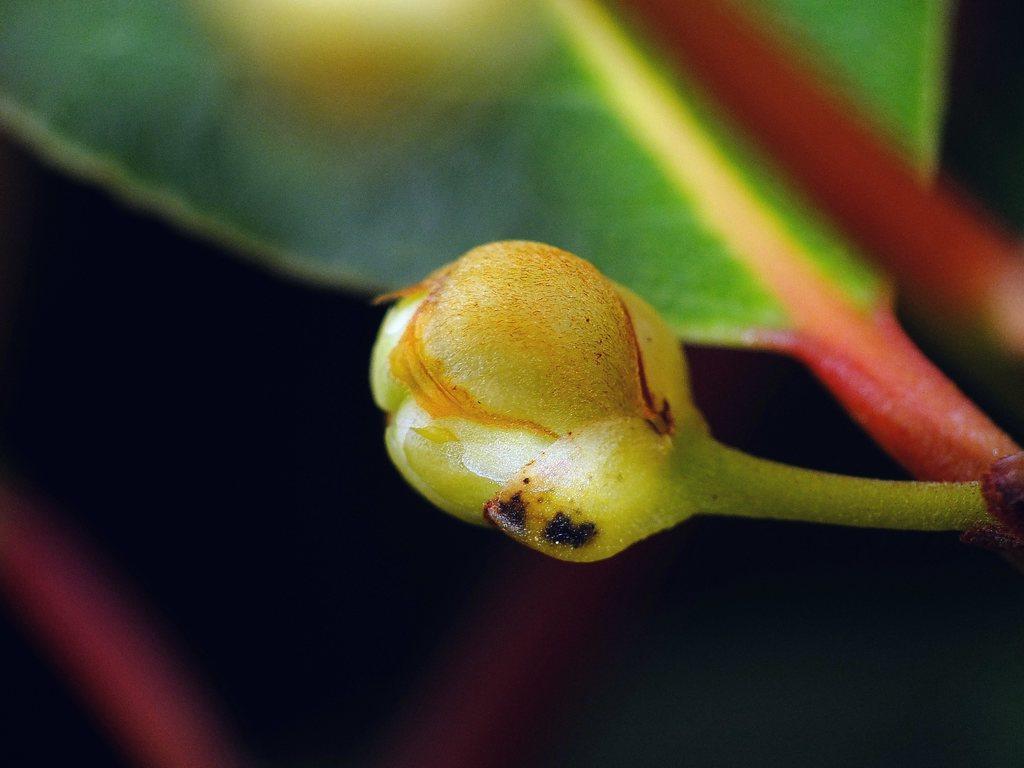Describe this image in one or two sentences. In this image there is a bud and a leaf. 